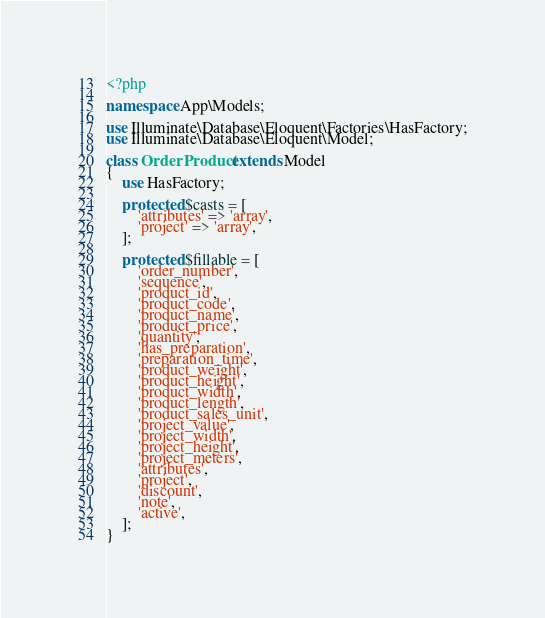<code> <loc_0><loc_0><loc_500><loc_500><_PHP_><?php

namespace App\Models;

use Illuminate\Database\Eloquent\Factories\HasFactory;
use Illuminate\Database\Eloquent\Model;

class OrderProduct extends Model
{
    use HasFactory;

    protected $casts = [
        'attributes' => 'array',
        'project' => 'array',
    ];

    protected $fillable = [
        'order_number',
        'sequence',
        'product_id',
        'product_code',
        'product_name',
        'product_price',
        'quantity',
        'has_preparation',
        'preparation_time',
        'product_weight',
        'product_height',
        'product_width',
        'product_length',
        'product_sales_unit',
        'project_value',
        'project_width',
        'project_height',
        'project_meters',
        'attributes',
        'project',
        'discount',
        'note',
        'active',
    ];
}
</code> 